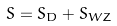Convert formula to latex. <formula><loc_0><loc_0><loc_500><loc_500>S = S _ { D } + S _ { W Z }</formula> 